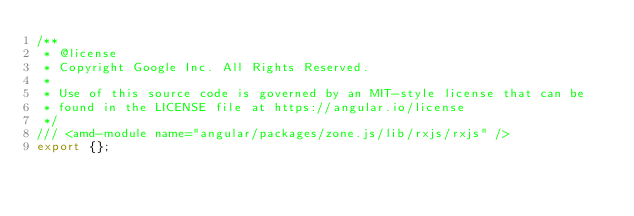Convert code to text. <code><loc_0><loc_0><loc_500><loc_500><_TypeScript_>/**
 * @license
 * Copyright Google Inc. All Rights Reserved.
 *
 * Use of this source code is governed by an MIT-style license that can be
 * found in the LICENSE file at https://angular.io/license
 */
/// <amd-module name="angular/packages/zone.js/lib/rxjs/rxjs" />
export {};
</code> 